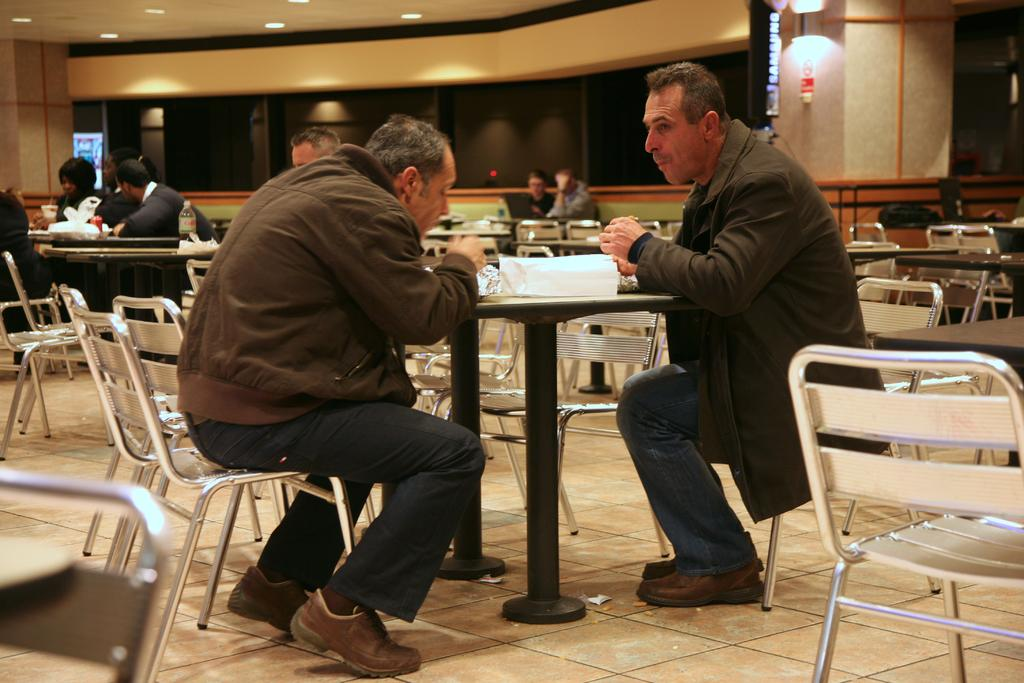How many people are visible in the image? There are two persons sitting in the image. What are the two persons doing in the image? The two persons are eating. Where are the two persons sitting? They are sitting in front of a table. Are there any other people present in the image? Yes, there are other people sitting beside them. What type of art can be seen hanging on the walls in the image? There is no art visible on the walls in the image. What act are the two persons performing in the image? The two persons are not performing any act; they are simply eating. 